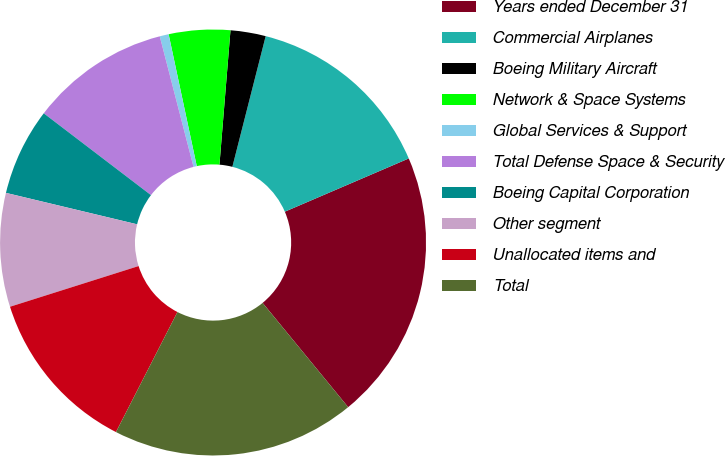Convert chart. <chart><loc_0><loc_0><loc_500><loc_500><pie_chart><fcel>Years ended December 31<fcel>Commercial Airplanes<fcel>Boeing Military Aircraft<fcel>Network & Space Systems<fcel>Global Services & Support<fcel>Total Defense Space & Security<fcel>Boeing Capital Corporation<fcel>Other segment<fcel>Unallocated items and<fcel>Total<nl><fcel>20.52%<fcel>14.57%<fcel>2.67%<fcel>4.65%<fcel>0.68%<fcel>10.6%<fcel>6.63%<fcel>8.62%<fcel>12.59%<fcel>18.47%<nl></chart> 